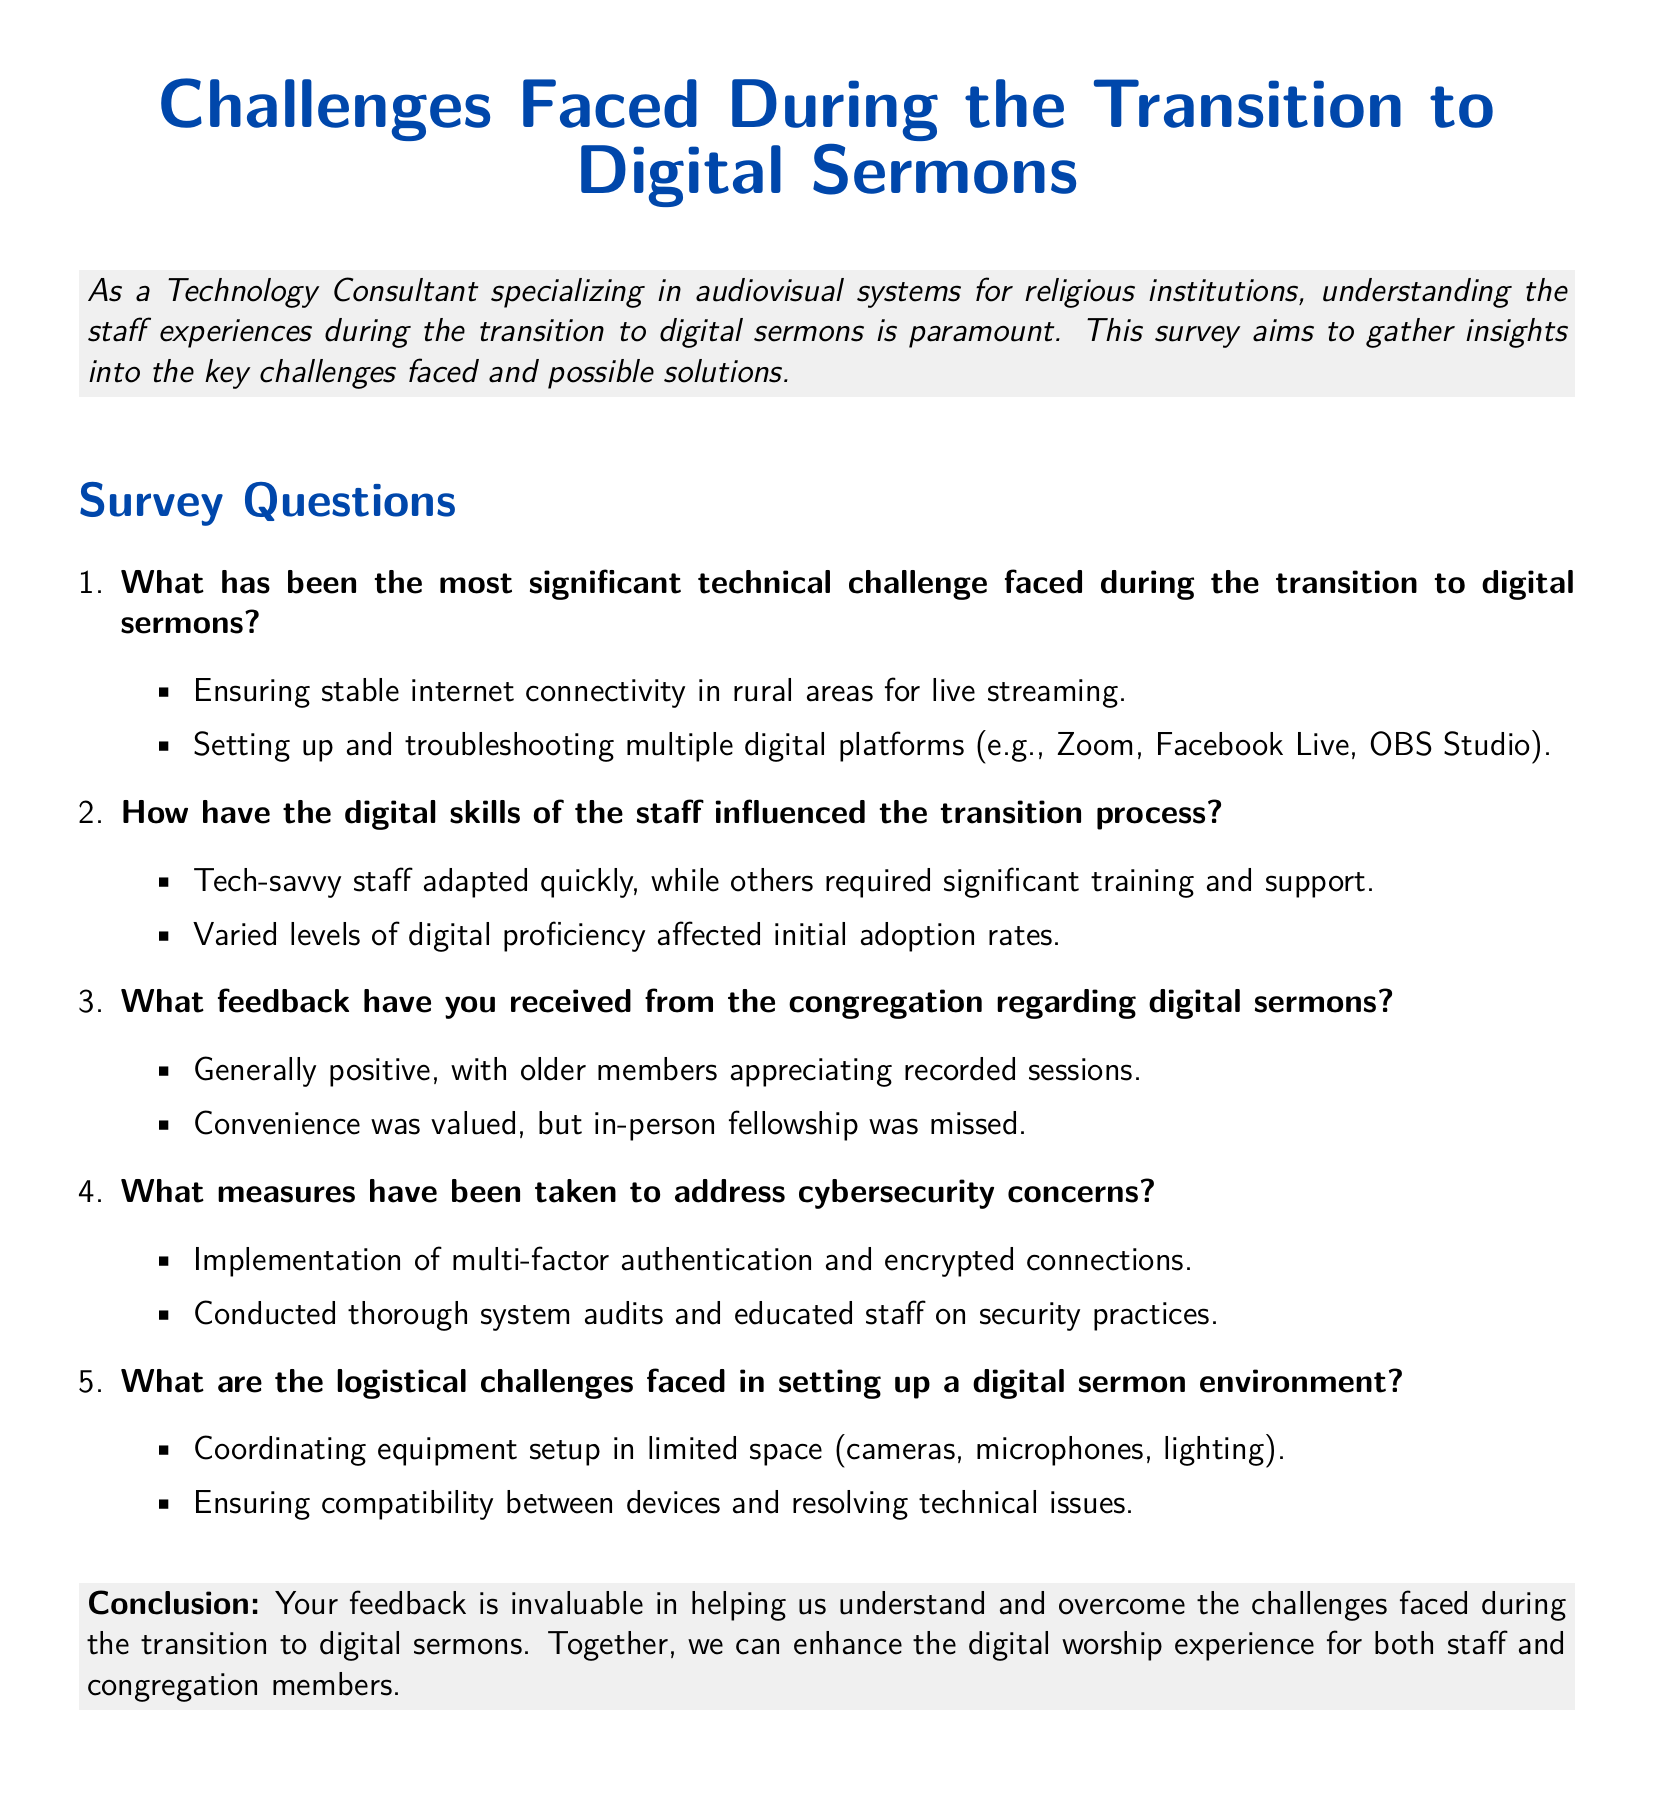What is the main focus of the survey? The survey aims to gather insights into the key challenges faced during the transition to digital sermons and possible solutions.
Answer: Key challenges What is one significant technical challenge mentioned? The document lists specific technical challenges, including ensuring stable internet connectivity.
Answer: Stable internet connectivity How have digital skills of staff influenced the transition? The experiences were characterized by varying levels of digital proficiency among staff, impacting adoption rates.
Answer: Varied levels of digital proficiency What feedback did the congregation provide regarding digital sermons? The feedback indicated that congregation members generally appreciated the convenience of digital sermons, while missing in-person fellowship.
Answer: Positive feedback What cybersecurity measure was implemented? The document mentions the implementation of multi-factor authentication as a measure against cybersecurity concerns.
Answer: Multi-factor authentication What logistical challenge is mentioned in setting up the digital sermon environment? The document highlights challenges such as coordinating equipment setup in limited space.
Answer: Limited space for setup What type of document is this survey categorized as? This document is categorized as a survey form focused on staff experiences.
Answer: Survey form How does the survey conclude? The conclusion emphasizes the importance of feedback in overcoming challenges during the transition to digital sermons.
Answer: Importance of feedback 